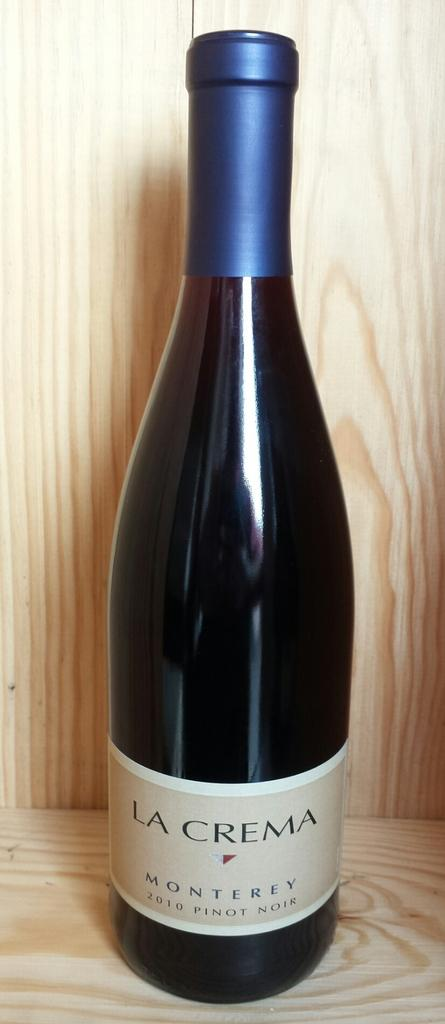<image>
Present a compact description of the photo's key features. A bottle of La Crema Monterey 2010 Pinot Noir sits on a wood display. 